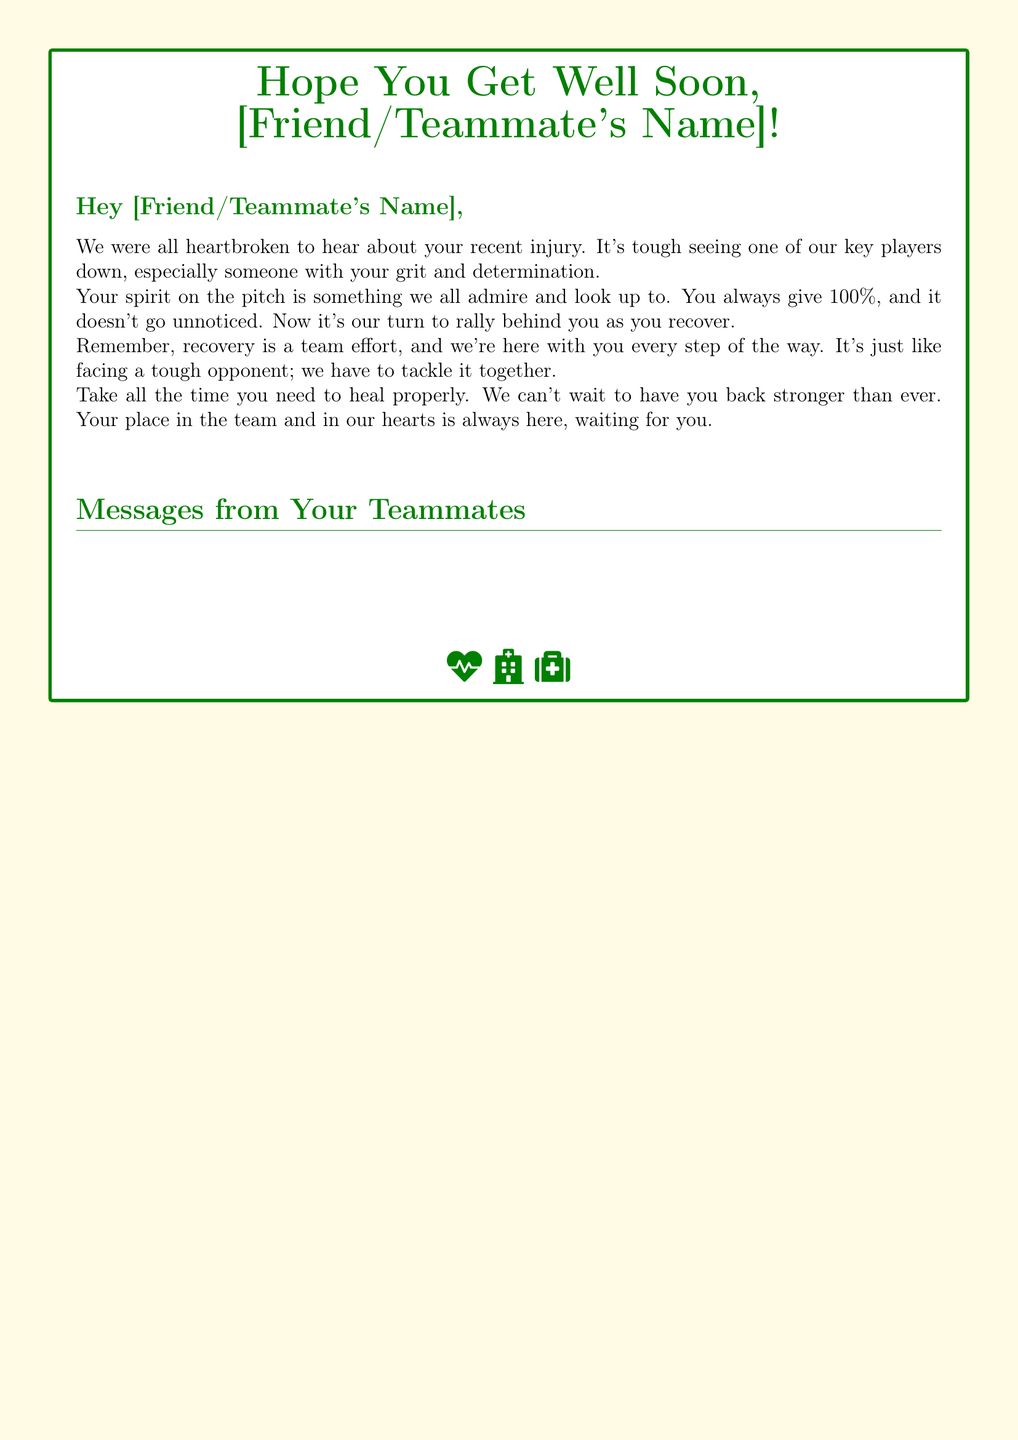What is the color theme used in the card? The card uses ugandagreen and ugandayellow as its color theme.
Answer: ugandagreen and ugandayellow How many messages are from teammates? There are four messages from teammates in the document.
Answer: four Who is the first teammate mentioned? The first teammate mentioned is Dennis Onyango in the document.
Answer: Dennis Onyango What sentiment is expressed in the card? The card expresses a supportive sentiment wishing a teammate a speedy recovery.
Answer: supportive What does the icon at the bottom symbolize? The icons at the bottom symbolize health and wellness, representing hope and recovery.
Answer: health and wellness What should the injured player take time to do? The injured player should take time to heal properly.
Answer: heal properly What is the name of the second teammate mentioned? The second teammate mentioned is Emmanuel Okwi.
Answer: Emmanuel Okwi What is the tone of the overall message in the card? The overall message in the card has a positive and encouraging tone.
Answer: positive and encouraging 